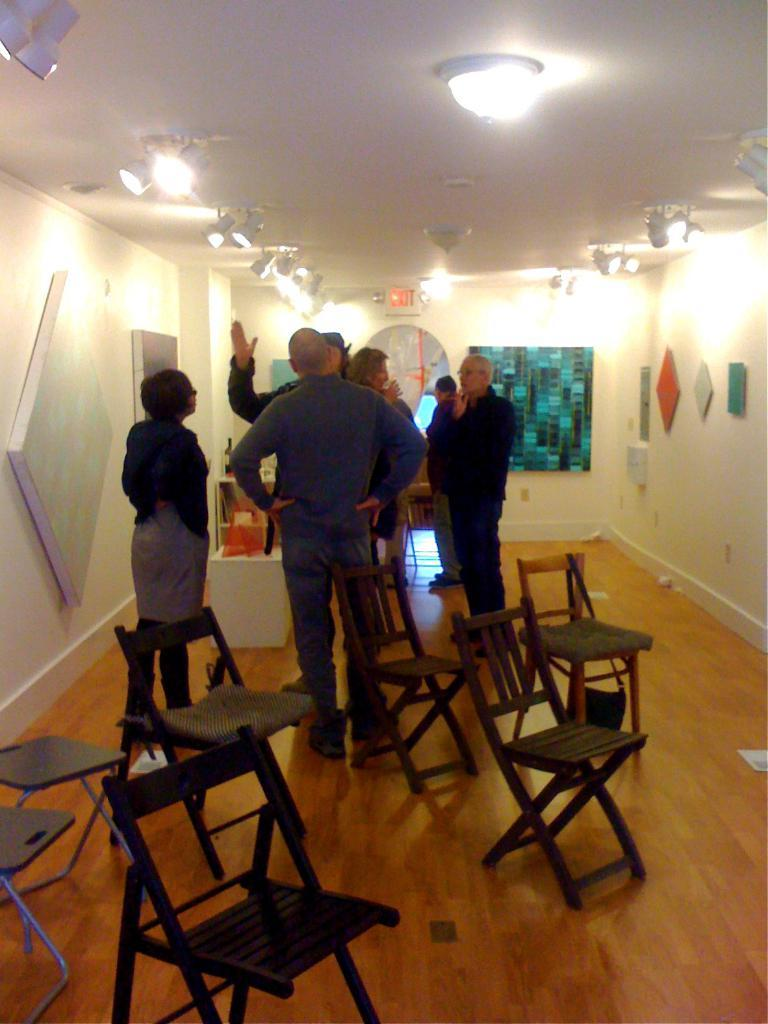How many people are in the image? There is a group of people in the image, but the exact number is not specified. What are the people doing in the image? The people are standing on the floor. What type of furniture is present in the image? There are chairs in the image. What is the color of the wall in the image? There is a white wall in the image. What is attached to the wall in the image? There are lights on the wall. What flavor of ink is being used by the people in the image? There is no ink present in the image, and therefore no flavor can be determined. 